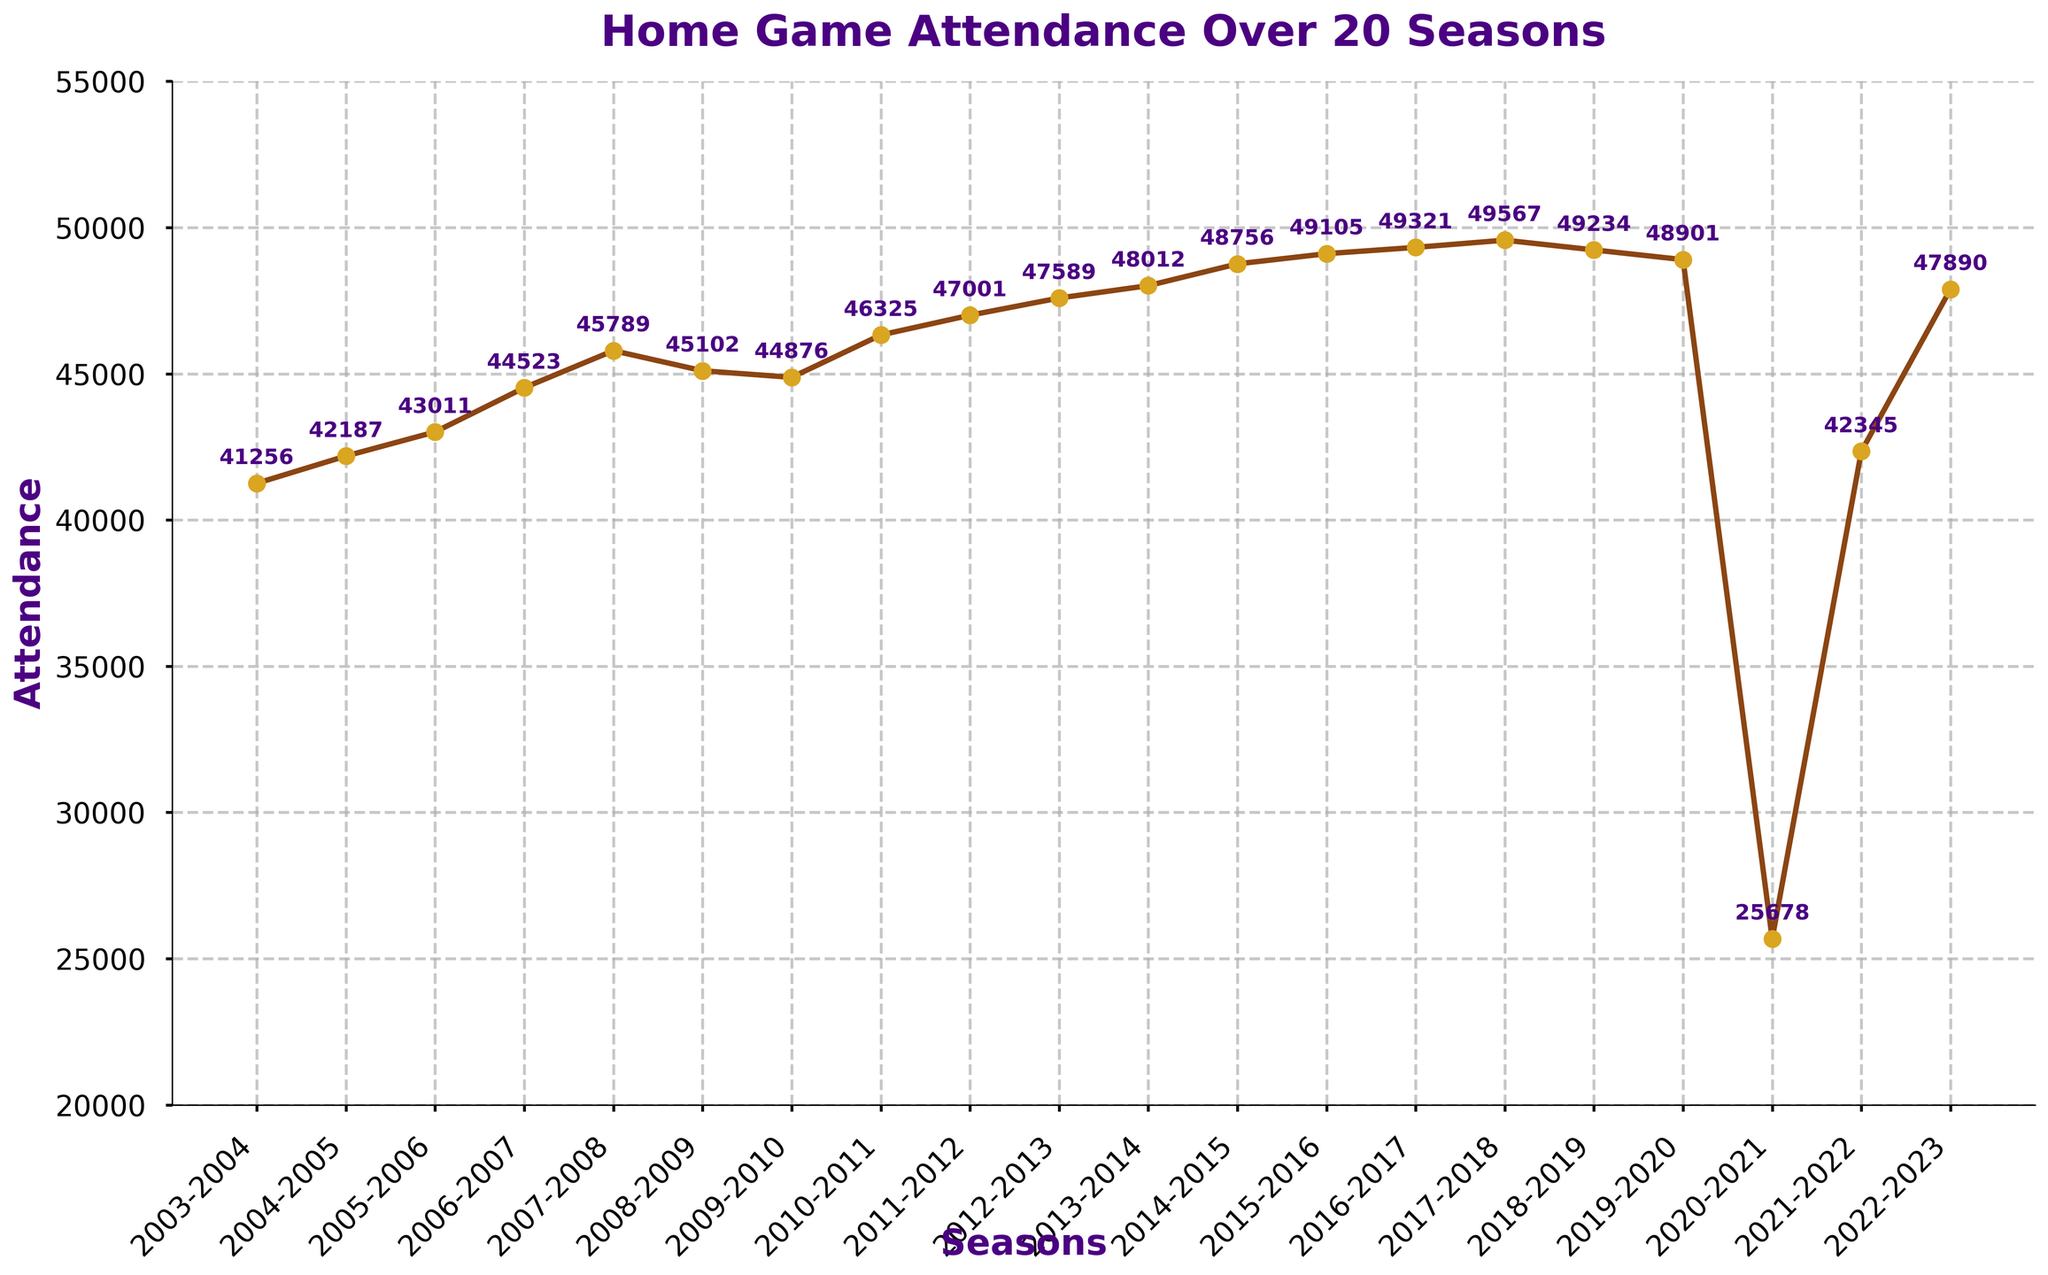Which season had the highest attendance? Visual inspection shows the peak of the line plot. Notably, the mark for the 2017-2018 season is the highest on the y-axis.
Answer: 2017-2018 What was the attendance difference between the 2012-2013 and 2014-2015 seasons? Subtract the attendance of the 2012-2013 season from that of the 2014-2015 season. 48756 - 47589 = 1167.
Answer: 1167 How did the attendance change from the 2019-2020 season to the 2020-2021 season? The visual drop between these two seasons is sharp. Subtract the attendance of the 2020-2021 season from that of the 2019-2020 season. 48901 - 25678 = 23223.
Answer: Decreased by 23223 Which seasons had a decrease in attendance compared to their previous seasons? Check the plot for a downward trend between consecutive seasons. These include 2007-2008 to 2008-2009, and 2018-2019 to 2019-2020, 2019-2020 to 2020-2021, and 2021-2022 to 2022-2023.
Answer: 2008-2009, 2018-2019, 2019-2020, 2021-2022 What is the average attendance from 2003-2004 to 2022-2023, excluding the 2020-2021 season? Calculate the sum of all the attendance values excluding 2020-2021, then divide by 19 (number of seasons). The sum is (41256+42187+43011+44523+45789+45102+44876+46325+47001+47589+48012+48756+49105+49321+49567+49234+48901+42345+47890) = 874790. So, the average is 874790/19 ≈ 46042.
Answer: 46042 How did the attendance trend change after the 2020-2021 season? The plot marks a drastic increase from 25678 in 2020-2021 to 42345 in 2021-2022, followed by another rise to 47890 in 2022-2023.
Answer: Increased Compare the attendance figures of the first five seasons to the last five seasons. Which had a higher average attendance? Calculate the average attendance for the first five seasons: (41256+42187+43011+44523+45789)/5 = 43353.2. 
Then, for the last five seasons: (49567+49234+48901+25678+42345)/5 = 43145.
Compare these averages to conclude that the first five seasons had a slightly higher attendance.
Answer: 43353.2 vs. 43145, so first five seasons What notable trend is observed in the attendance figures for the 2020-2021 season compared to all other seasons? Visual observation shows a significant drop in attendance in the 2020-2021 season, almost halving from around 49000 to approximately 25700.
Answer: Sharp decline When did the attendance figures surpass the 48000 mark for the first time? Identify the first data point exceeding 48000 on the plot. This occurs in the 2013-2014 season.
Answer: 2013-2014 How does the attendance in the 2022-2023 season compare to the 2015-2016 season? The 2022-2023 attendance is 47890, while the 2015-2016 attendance is 49105. Comparison shows the attendance decreased.
Answer: Decreased 